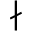Convert formula to latex. <formula><loc_0><loc_0><loc_500><loc_500>\nmid</formula> 